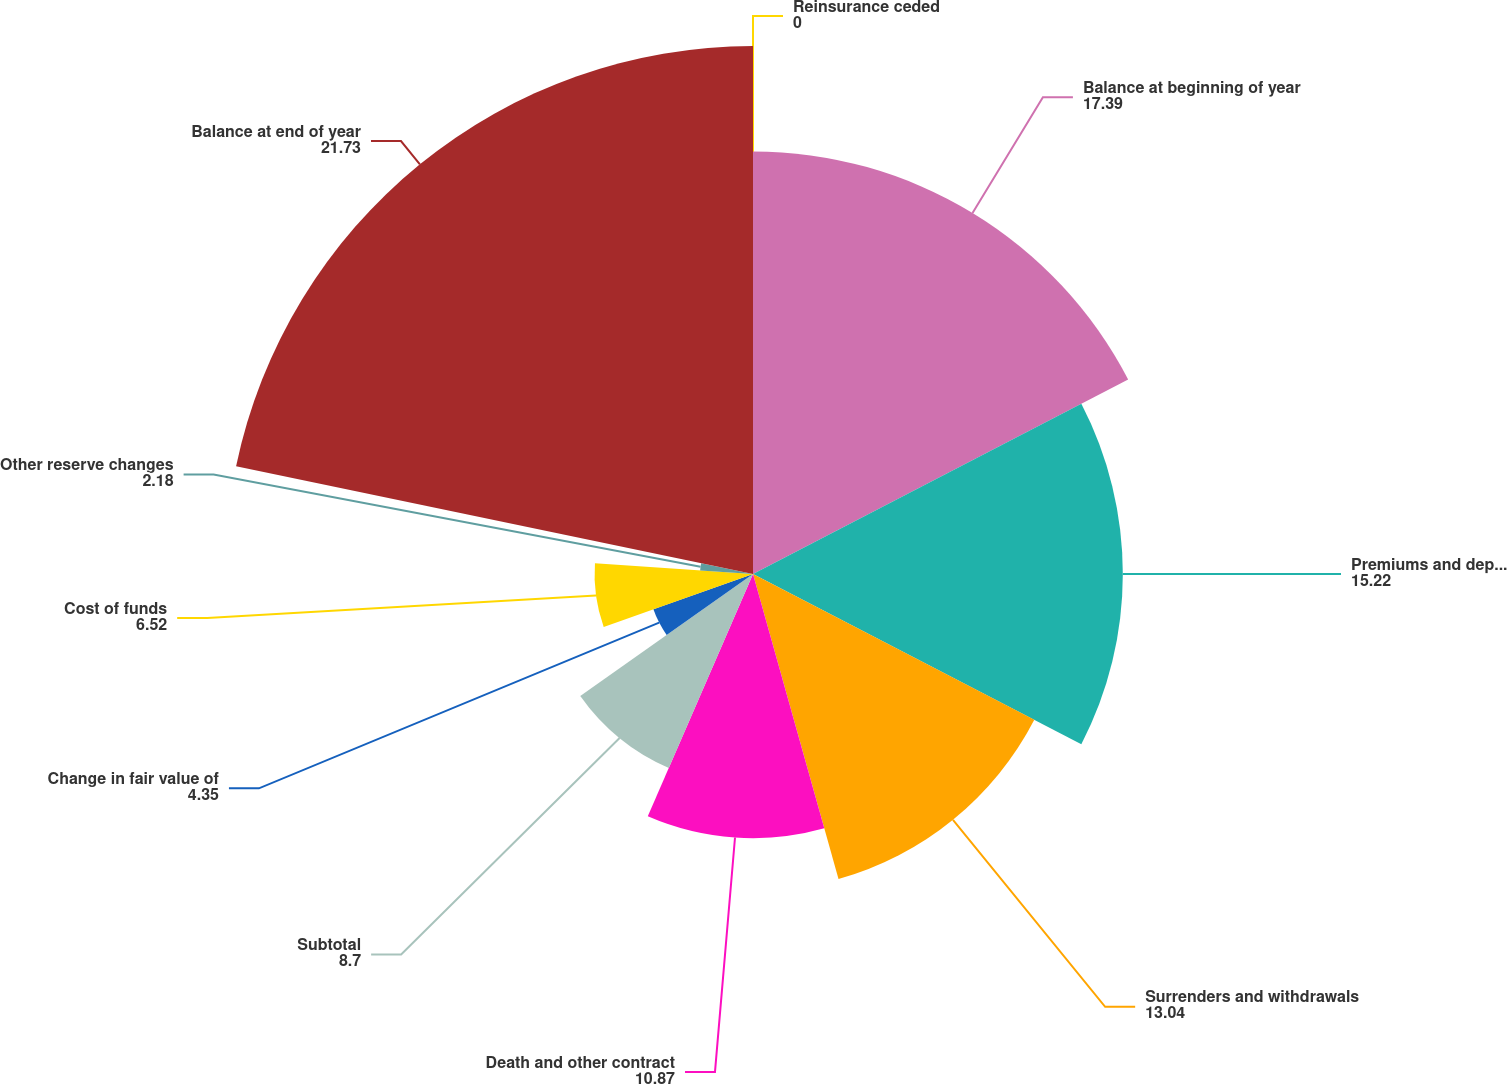Convert chart to OTSL. <chart><loc_0><loc_0><loc_500><loc_500><pie_chart><fcel>Balance at beginning of year<fcel>Premiums and deposits<fcel>Surrenders and withdrawals<fcel>Death and other contract<fcel>Subtotal<fcel>Change in fair value of<fcel>Cost of funds<fcel>Other reserve changes<fcel>Balance at end of year<fcel>Reinsurance ceded<nl><fcel>17.39%<fcel>15.22%<fcel>13.04%<fcel>10.87%<fcel>8.7%<fcel>4.35%<fcel>6.52%<fcel>2.18%<fcel>21.73%<fcel>0.0%<nl></chart> 